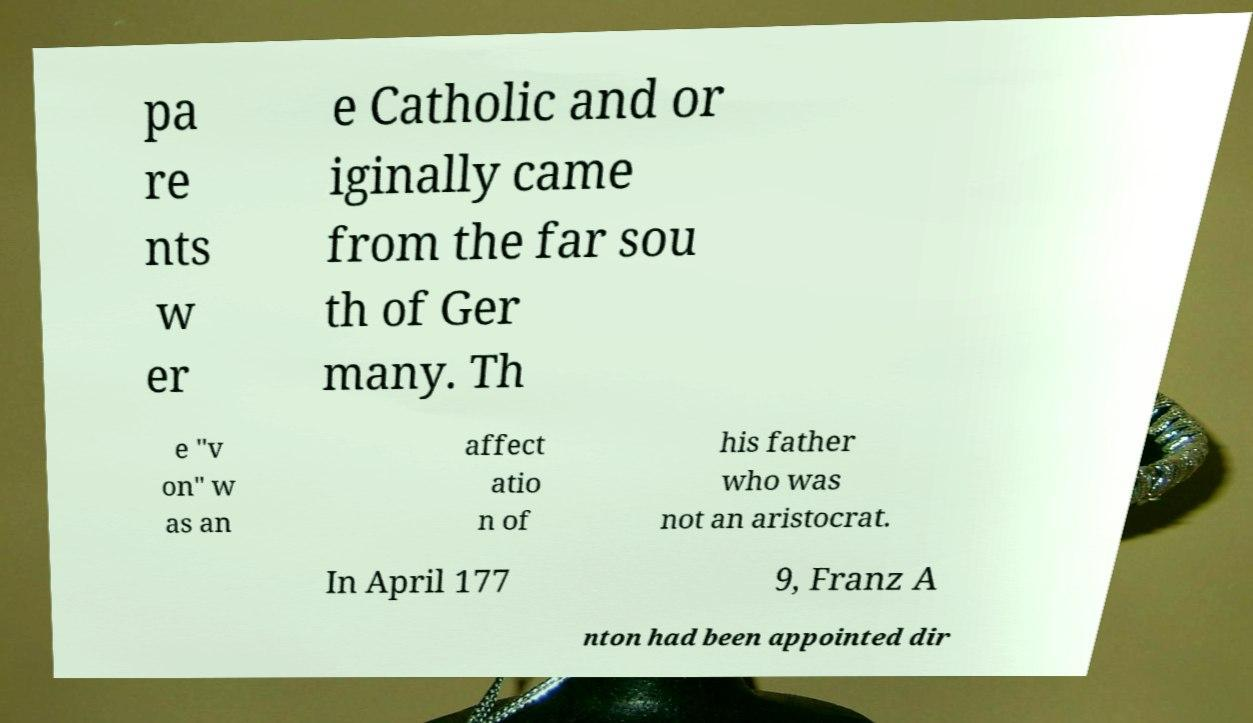Could you assist in decoding the text presented in this image and type it out clearly? pa re nts w er e Catholic and or iginally came from the far sou th of Ger many. Th e "v on" w as an affect atio n of his father who was not an aristocrat. In April 177 9, Franz A nton had been appointed dir 